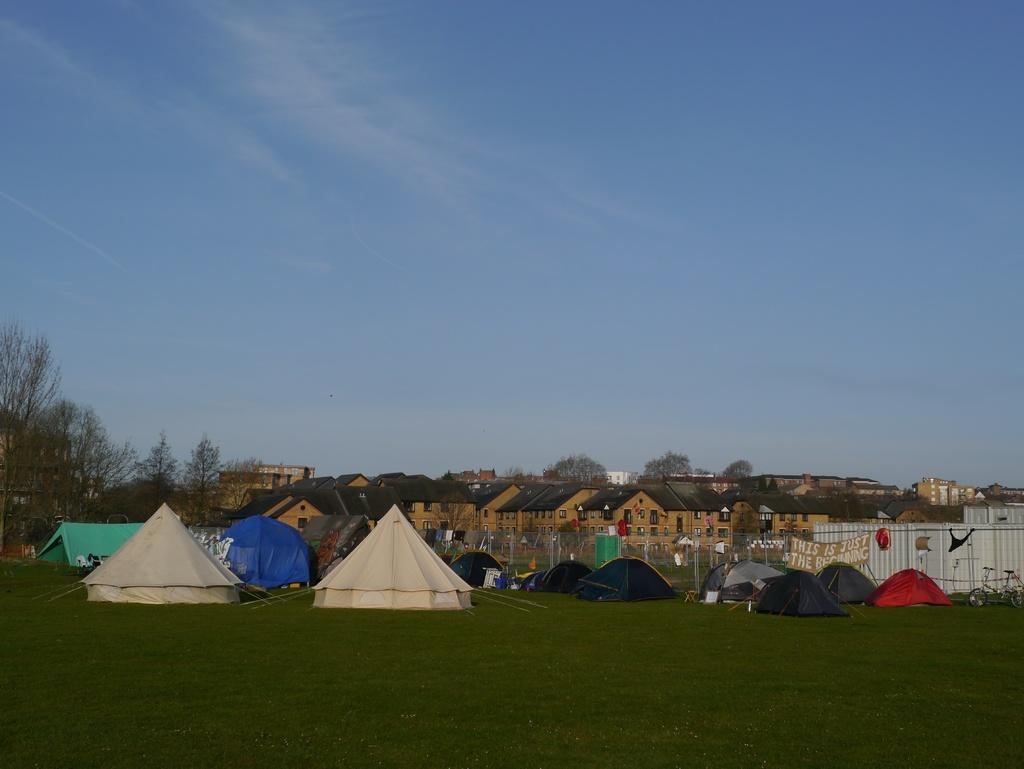What type of structures can be seen in the image? There are tents and buildings in the image. What type of natural elements are present in the image? There are trees, poles, and grass in the image. What type of transportation is visible in the image? There is a bicycle in the image. What type of signage is present in the image? There is a poster with text in the image. What can be seen in the background of the image? The sky with clouds is visible in the background of the image. What type of attraction can be seen in the image? There is no attraction present in the image; it features tents, buildings, trees, poles, grass, a bicycle, a poster with text, and a sky with clouds. What type of branch is holding up the bicycle in the image? There is no branch present in the image; the bicycle is not being held up by any visible branches. 